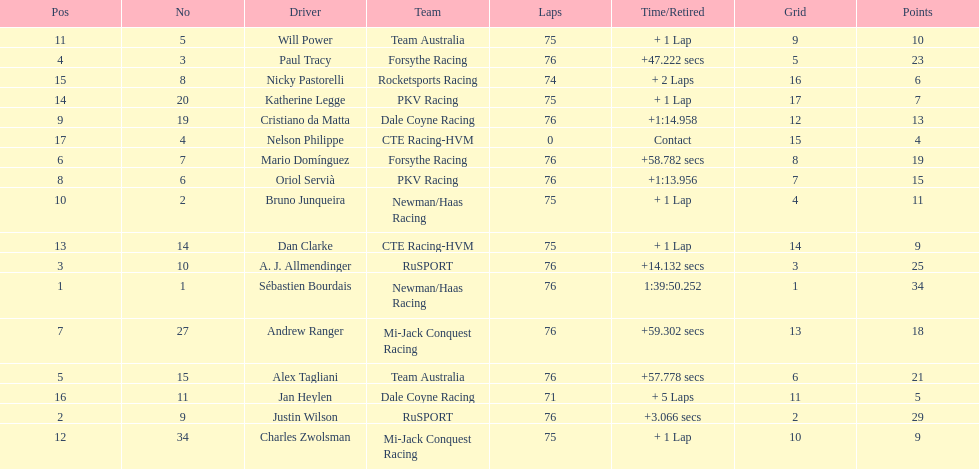How many drivers were competing for brazil? 2. 